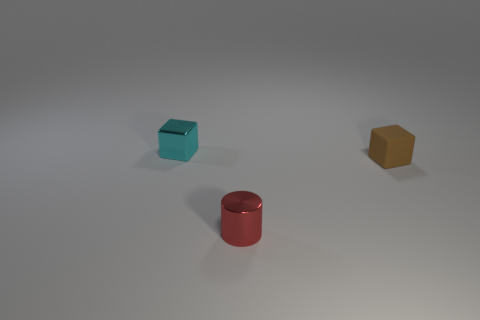Add 2 gray balls. How many objects exist? 5 Subtract all cyan blocks. How many blocks are left? 1 Subtract all cubes. How many objects are left? 1 Subtract all gray cubes. Subtract all brown balls. How many cubes are left? 2 Subtract all small red metal objects. Subtract all shiny blocks. How many objects are left? 1 Add 2 small shiny cylinders. How many small shiny cylinders are left? 3 Add 1 small red metallic cylinders. How many small red metallic cylinders exist? 2 Subtract 0 gray cylinders. How many objects are left? 3 